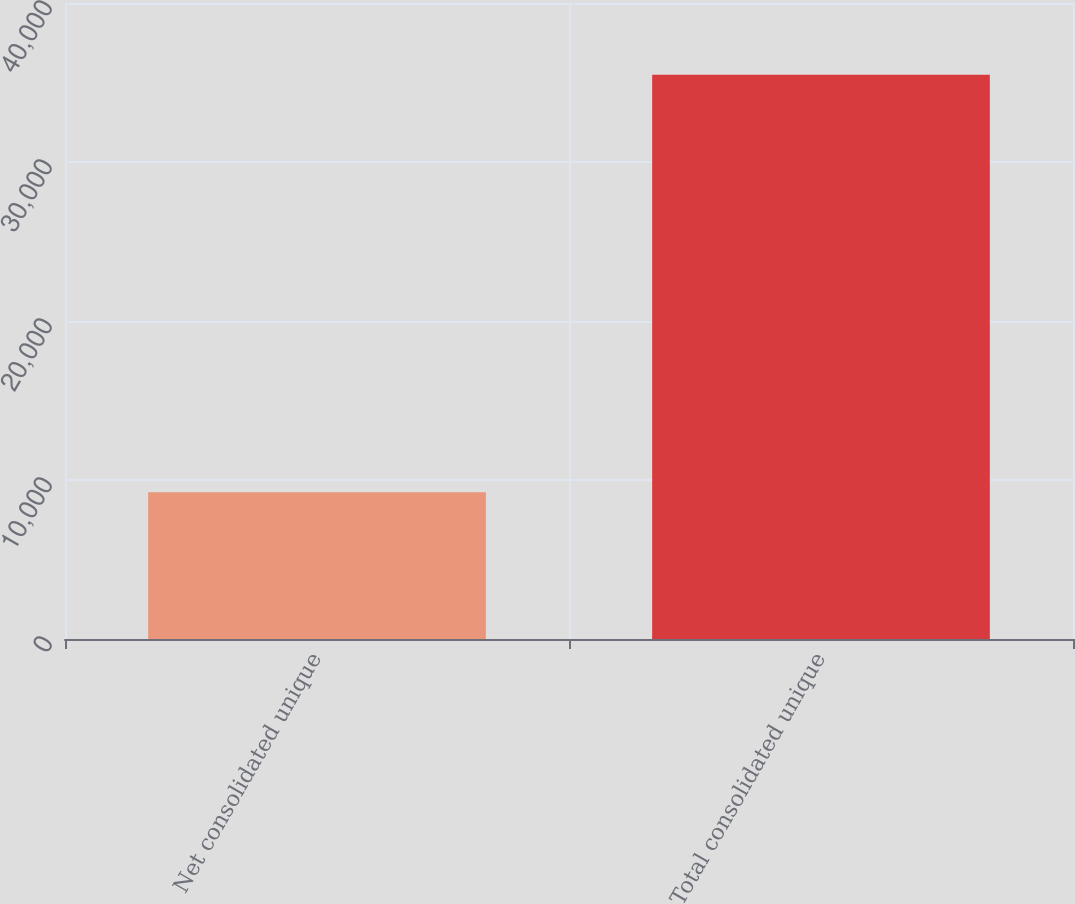<chart> <loc_0><loc_0><loc_500><loc_500><bar_chart><fcel>Net consolidated unique<fcel>Total consolidated unique<nl><fcel>9236<fcel>35489<nl></chart> 